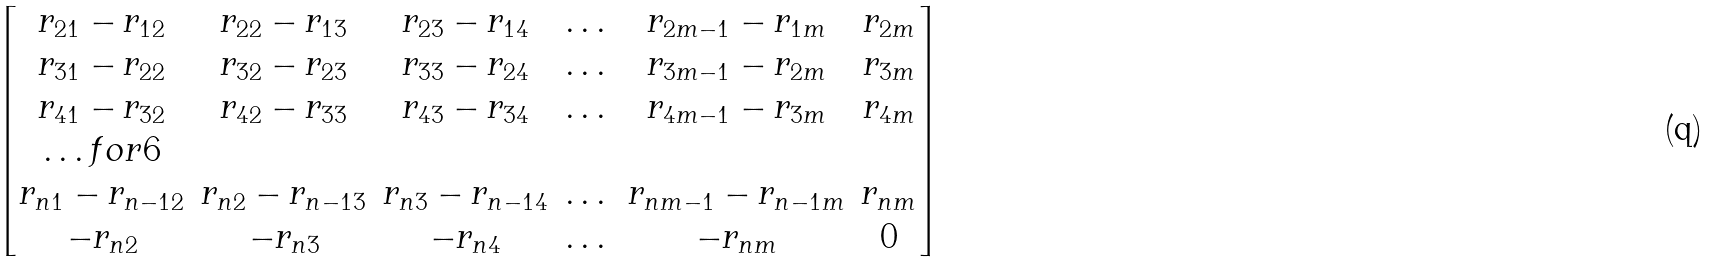<formula> <loc_0><loc_0><loc_500><loc_500>\begin{bmatrix} r _ { 2 1 } - r _ { 1 2 } & r _ { 2 2 } - r _ { 1 3 } & r _ { 2 3 } - r _ { 1 4 } & \dots & r _ { 2 m - 1 } - r _ { 1 m } & r _ { 2 m } \\ r _ { 3 1 } - r _ { 2 2 } & r _ { 3 2 } - r _ { 2 3 } & r _ { 3 3 } - r _ { 2 4 } & \dots & r _ { 3 m - 1 } - r _ { 2 m } & r _ { 3 m } \\ r _ { 4 1 } - r _ { 3 2 } & r _ { 4 2 } - r _ { 3 3 } & r _ { 4 3 } - r _ { 3 4 } & \dots & r _ { 4 m - 1 } - r _ { 3 m } & r _ { 4 m } \\ \hdots f o r { 6 } \\ r _ { n 1 } - r _ { n - 1 2 } & r _ { n 2 } - r _ { n - 1 3 } & r _ { n 3 } - r _ { n - 1 4 } & \dots & r _ { n m - 1 } - r _ { n - 1 m } & r _ { n m } \\ - r _ { n 2 } & - r _ { n 3 } & - r _ { n 4 } & \dots & - r _ { n m } & 0 \\ \end{bmatrix}</formula> 